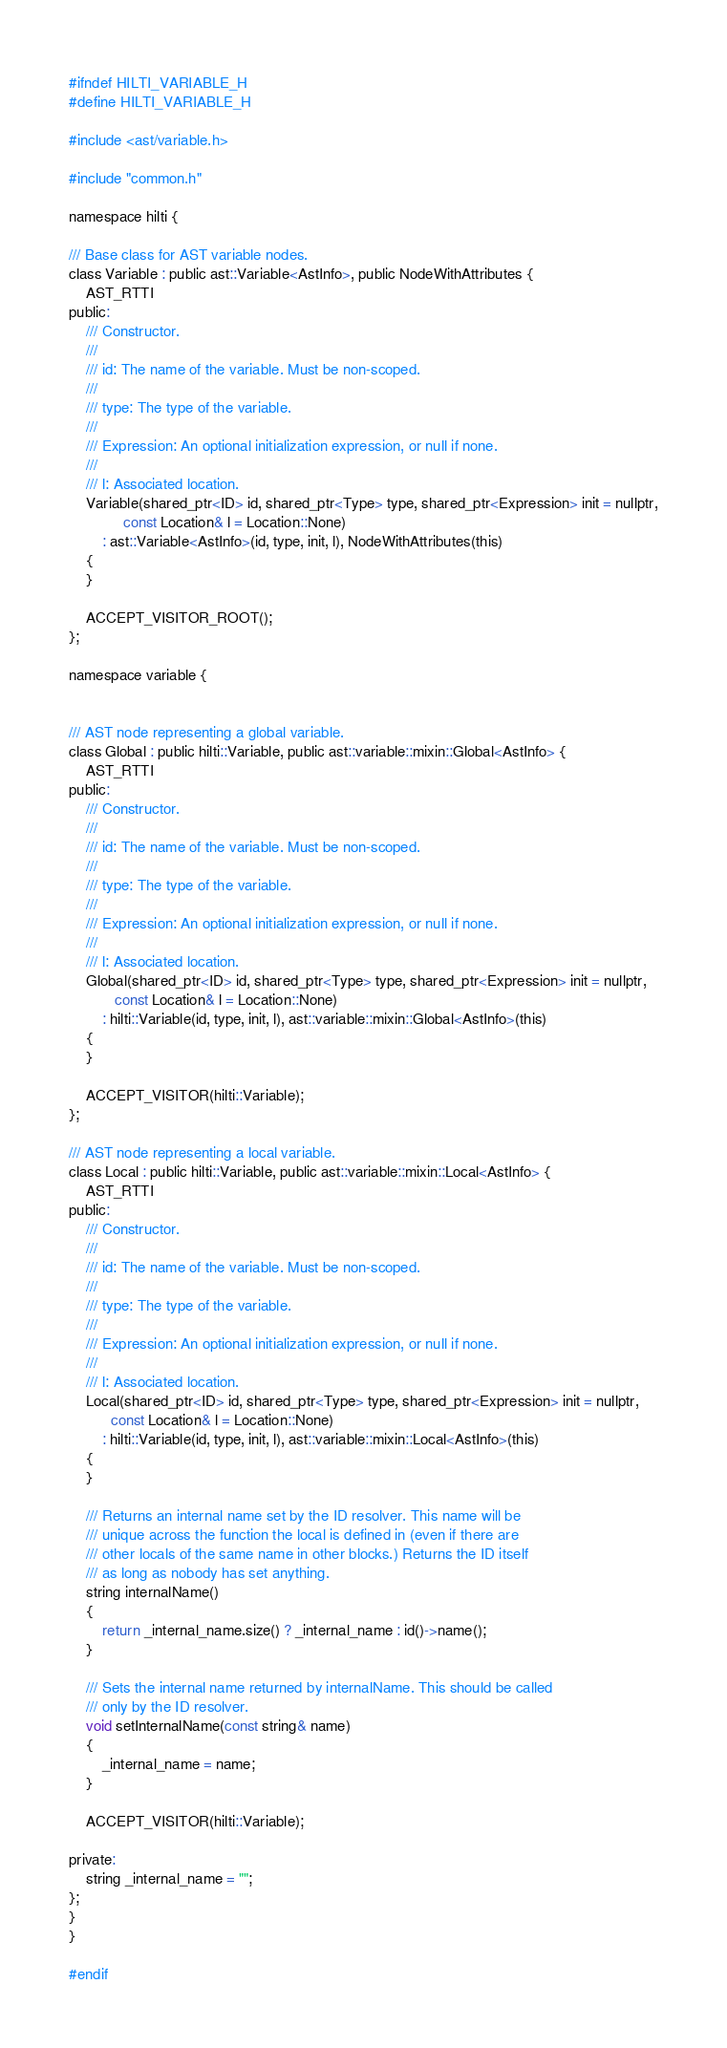Convert code to text. <code><loc_0><loc_0><loc_500><loc_500><_C_>
#ifndef HILTI_VARIABLE_H
#define HILTI_VARIABLE_H

#include <ast/variable.h>

#include "common.h"

namespace hilti {

/// Base class for AST variable nodes.
class Variable : public ast::Variable<AstInfo>, public NodeWithAttributes {
    AST_RTTI
public:
    /// Constructor.
    ///
    /// id: The name of the variable. Must be non-scoped.
    ///
    /// type: The type of the variable.
    ///
    /// Expression: An optional initialization expression, or null if none.
    ///
    /// l: Associated location.
    Variable(shared_ptr<ID> id, shared_ptr<Type> type, shared_ptr<Expression> init = nullptr,
             const Location& l = Location::None)
        : ast::Variable<AstInfo>(id, type, init, l), NodeWithAttributes(this)
    {
    }

    ACCEPT_VISITOR_ROOT();
};

namespace variable {


/// AST node representing a global variable.
class Global : public hilti::Variable, public ast::variable::mixin::Global<AstInfo> {
    AST_RTTI
public:
    /// Constructor.
    ///
    /// id: The name of the variable. Must be non-scoped.
    ///
    /// type: The type of the variable.
    ///
    /// Expression: An optional initialization expression, or null if none.
    ///
    /// l: Associated location.
    Global(shared_ptr<ID> id, shared_ptr<Type> type, shared_ptr<Expression> init = nullptr,
           const Location& l = Location::None)
        : hilti::Variable(id, type, init, l), ast::variable::mixin::Global<AstInfo>(this)
    {
    }

    ACCEPT_VISITOR(hilti::Variable);
};

/// AST node representing a local variable.
class Local : public hilti::Variable, public ast::variable::mixin::Local<AstInfo> {
    AST_RTTI
public:
    /// Constructor.
    ///
    /// id: The name of the variable. Must be non-scoped.
    ///
    /// type: The type of the variable.
    ///
    /// Expression: An optional initialization expression, or null if none.
    ///
    /// l: Associated location.
    Local(shared_ptr<ID> id, shared_ptr<Type> type, shared_ptr<Expression> init = nullptr,
          const Location& l = Location::None)
        : hilti::Variable(id, type, init, l), ast::variable::mixin::Local<AstInfo>(this)
    {
    }

    /// Returns an internal name set by the ID resolver. This name will be
    /// unique across the function the local is defined in (even if there are
    /// other locals of the same name in other blocks.) Returns the ID itself
    /// as long as nobody has set anything.
    string internalName()
    {
        return _internal_name.size() ? _internal_name : id()->name();
    }

    /// Sets the internal name returned by internalName. This should be called
    /// only by the ID resolver.
    void setInternalName(const string& name)
    {
        _internal_name = name;
    }

    ACCEPT_VISITOR(hilti::Variable);

private:
    string _internal_name = "";
};
}
}

#endif
</code> 